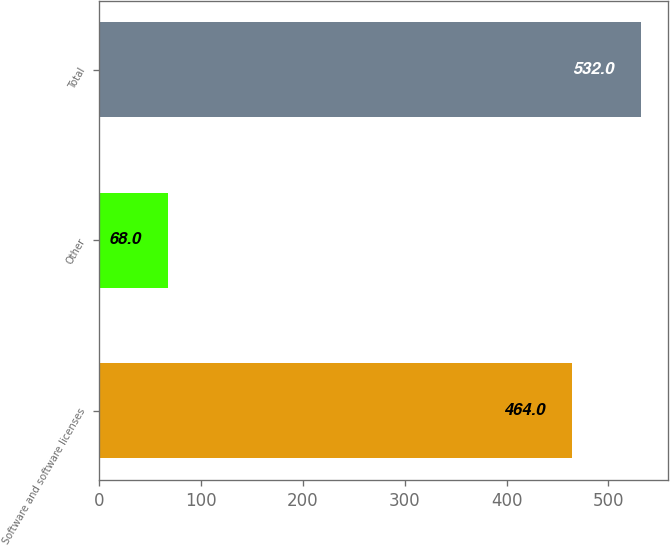<chart> <loc_0><loc_0><loc_500><loc_500><bar_chart><fcel>Software and software licenses<fcel>Other<fcel>Total<nl><fcel>464<fcel>68<fcel>532<nl></chart> 